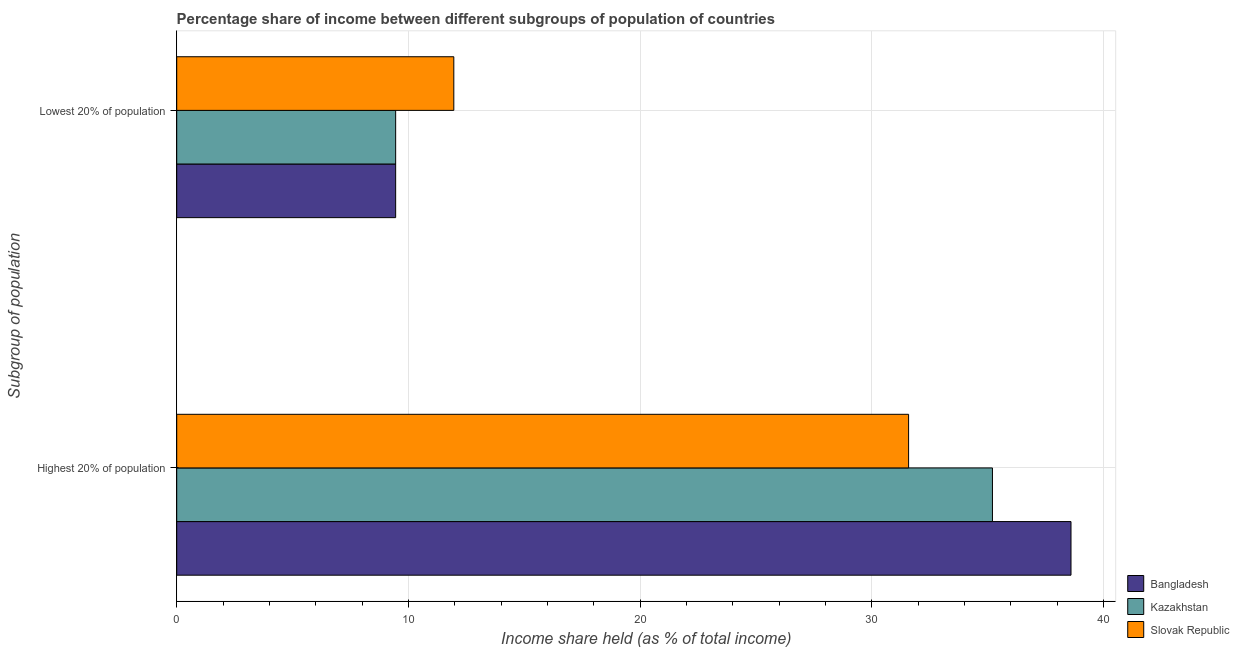How many different coloured bars are there?
Keep it short and to the point. 3. How many bars are there on the 1st tick from the bottom?
Your response must be concise. 3. What is the label of the 1st group of bars from the top?
Keep it short and to the point. Lowest 20% of population. What is the income share held by highest 20% of the population in Slovak Republic?
Make the answer very short. 31.59. Across all countries, what is the maximum income share held by lowest 20% of the population?
Your answer should be compact. 11.96. Across all countries, what is the minimum income share held by highest 20% of the population?
Your answer should be compact. 31.59. In which country was the income share held by highest 20% of the population minimum?
Your answer should be very brief. Slovak Republic. What is the total income share held by highest 20% of the population in the graph?
Offer a very short reply. 105.4. What is the difference between the income share held by lowest 20% of the population in Slovak Republic and that in Bangladesh?
Your response must be concise. 2.51. What is the difference between the income share held by lowest 20% of the population in Slovak Republic and the income share held by highest 20% of the population in Kazakhstan?
Ensure brevity in your answer.  -23.25. What is the average income share held by lowest 20% of the population per country?
Offer a very short reply. 10.29. What is the difference between the income share held by highest 20% of the population and income share held by lowest 20% of the population in Kazakhstan?
Make the answer very short. 25.76. In how many countries, is the income share held by highest 20% of the population greater than 26 %?
Offer a very short reply. 3. What is the ratio of the income share held by lowest 20% of the population in Slovak Republic to that in Kazakhstan?
Make the answer very short. 1.27. Is the income share held by highest 20% of the population in Kazakhstan less than that in Slovak Republic?
Give a very brief answer. No. What does the 3rd bar from the top in Lowest 20% of population represents?
Make the answer very short. Bangladesh. What does the 3rd bar from the bottom in Lowest 20% of population represents?
Make the answer very short. Slovak Republic. How many bars are there?
Ensure brevity in your answer.  6. How many countries are there in the graph?
Offer a terse response. 3. Does the graph contain grids?
Provide a short and direct response. Yes. Where does the legend appear in the graph?
Your answer should be compact. Bottom right. How many legend labels are there?
Provide a short and direct response. 3. How are the legend labels stacked?
Provide a short and direct response. Vertical. What is the title of the graph?
Your response must be concise. Percentage share of income between different subgroups of population of countries. What is the label or title of the X-axis?
Ensure brevity in your answer.  Income share held (as % of total income). What is the label or title of the Y-axis?
Provide a short and direct response. Subgroup of population. What is the Income share held (as % of total income) in Bangladesh in Highest 20% of population?
Your answer should be very brief. 38.6. What is the Income share held (as % of total income) of Kazakhstan in Highest 20% of population?
Ensure brevity in your answer.  35.21. What is the Income share held (as % of total income) of Slovak Republic in Highest 20% of population?
Your answer should be very brief. 31.59. What is the Income share held (as % of total income) in Bangladesh in Lowest 20% of population?
Offer a very short reply. 9.45. What is the Income share held (as % of total income) of Kazakhstan in Lowest 20% of population?
Ensure brevity in your answer.  9.45. What is the Income share held (as % of total income) of Slovak Republic in Lowest 20% of population?
Your answer should be very brief. 11.96. Across all Subgroup of population, what is the maximum Income share held (as % of total income) of Bangladesh?
Provide a short and direct response. 38.6. Across all Subgroup of population, what is the maximum Income share held (as % of total income) of Kazakhstan?
Keep it short and to the point. 35.21. Across all Subgroup of population, what is the maximum Income share held (as % of total income) of Slovak Republic?
Your response must be concise. 31.59. Across all Subgroup of population, what is the minimum Income share held (as % of total income) in Bangladesh?
Provide a short and direct response. 9.45. Across all Subgroup of population, what is the minimum Income share held (as % of total income) in Kazakhstan?
Offer a terse response. 9.45. Across all Subgroup of population, what is the minimum Income share held (as % of total income) of Slovak Republic?
Your answer should be very brief. 11.96. What is the total Income share held (as % of total income) of Bangladesh in the graph?
Give a very brief answer. 48.05. What is the total Income share held (as % of total income) in Kazakhstan in the graph?
Ensure brevity in your answer.  44.66. What is the total Income share held (as % of total income) in Slovak Republic in the graph?
Your answer should be compact. 43.55. What is the difference between the Income share held (as % of total income) in Bangladesh in Highest 20% of population and that in Lowest 20% of population?
Ensure brevity in your answer.  29.15. What is the difference between the Income share held (as % of total income) in Kazakhstan in Highest 20% of population and that in Lowest 20% of population?
Keep it short and to the point. 25.76. What is the difference between the Income share held (as % of total income) of Slovak Republic in Highest 20% of population and that in Lowest 20% of population?
Keep it short and to the point. 19.63. What is the difference between the Income share held (as % of total income) of Bangladesh in Highest 20% of population and the Income share held (as % of total income) of Kazakhstan in Lowest 20% of population?
Keep it short and to the point. 29.15. What is the difference between the Income share held (as % of total income) of Bangladesh in Highest 20% of population and the Income share held (as % of total income) of Slovak Republic in Lowest 20% of population?
Offer a very short reply. 26.64. What is the difference between the Income share held (as % of total income) in Kazakhstan in Highest 20% of population and the Income share held (as % of total income) in Slovak Republic in Lowest 20% of population?
Offer a very short reply. 23.25. What is the average Income share held (as % of total income) in Bangladesh per Subgroup of population?
Provide a succinct answer. 24.02. What is the average Income share held (as % of total income) in Kazakhstan per Subgroup of population?
Your response must be concise. 22.33. What is the average Income share held (as % of total income) in Slovak Republic per Subgroup of population?
Your response must be concise. 21.77. What is the difference between the Income share held (as % of total income) in Bangladesh and Income share held (as % of total income) in Kazakhstan in Highest 20% of population?
Provide a succinct answer. 3.39. What is the difference between the Income share held (as % of total income) in Bangladesh and Income share held (as % of total income) in Slovak Republic in Highest 20% of population?
Keep it short and to the point. 7.01. What is the difference between the Income share held (as % of total income) in Kazakhstan and Income share held (as % of total income) in Slovak Republic in Highest 20% of population?
Your response must be concise. 3.62. What is the difference between the Income share held (as % of total income) of Bangladesh and Income share held (as % of total income) of Kazakhstan in Lowest 20% of population?
Ensure brevity in your answer.  0. What is the difference between the Income share held (as % of total income) in Bangladesh and Income share held (as % of total income) in Slovak Republic in Lowest 20% of population?
Provide a short and direct response. -2.51. What is the difference between the Income share held (as % of total income) in Kazakhstan and Income share held (as % of total income) in Slovak Republic in Lowest 20% of population?
Your response must be concise. -2.51. What is the ratio of the Income share held (as % of total income) in Bangladesh in Highest 20% of population to that in Lowest 20% of population?
Keep it short and to the point. 4.08. What is the ratio of the Income share held (as % of total income) in Kazakhstan in Highest 20% of population to that in Lowest 20% of population?
Ensure brevity in your answer.  3.73. What is the ratio of the Income share held (as % of total income) in Slovak Republic in Highest 20% of population to that in Lowest 20% of population?
Give a very brief answer. 2.64. What is the difference between the highest and the second highest Income share held (as % of total income) in Bangladesh?
Offer a very short reply. 29.15. What is the difference between the highest and the second highest Income share held (as % of total income) of Kazakhstan?
Ensure brevity in your answer.  25.76. What is the difference between the highest and the second highest Income share held (as % of total income) in Slovak Republic?
Give a very brief answer. 19.63. What is the difference between the highest and the lowest Income share held (as % of total income) in Bangladesh?
Offer a terse response. 29.15. What is the difference between the highest and the lowest Income share held (as % of total income) of Kazakhstan?
Provide a succinct answer. 25.76. What is the difference between the highest and the lowest Income share held (as % of total income) in Slovak Republic?
Ensure brevity in your answer.  19.63. 